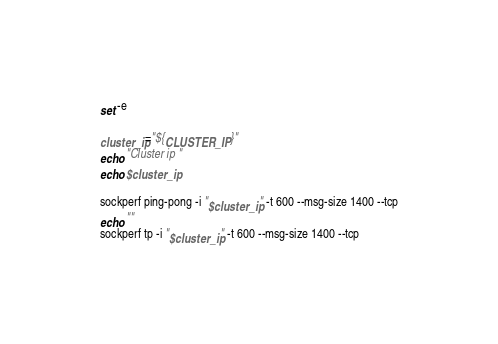<code> <loc_0><loc_0><loc_500><loc_500><_Bash_>set -e

cluster_ip="${CLUSTER_IP}"
echo "Cluster ip "
echo $cluster_ip

sockperf ping-pong -i "$cluster_ip" -t 600 --msg-size 1400 --tcp
echo ""
sockperf tp -i "$cluster_ip" -t 600 --msg-size 1400 --tcp</code> 